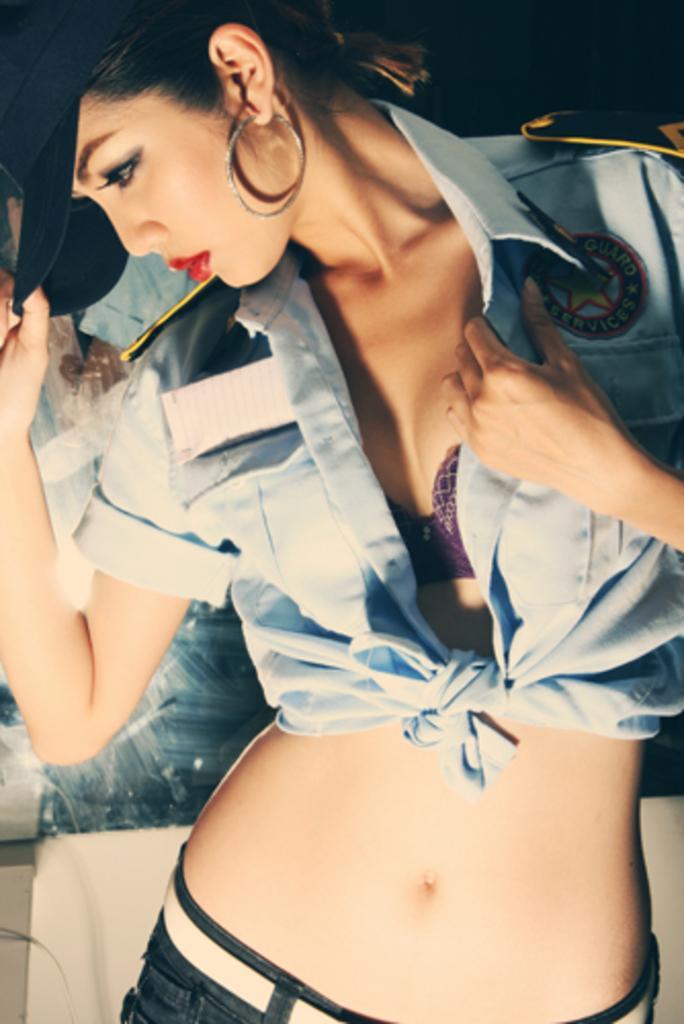In one or two sentences, can you explain what this image depicts? In this image we can see there is a person standing and holding a cap. And at the back it looks like a poster attached to the wall. 